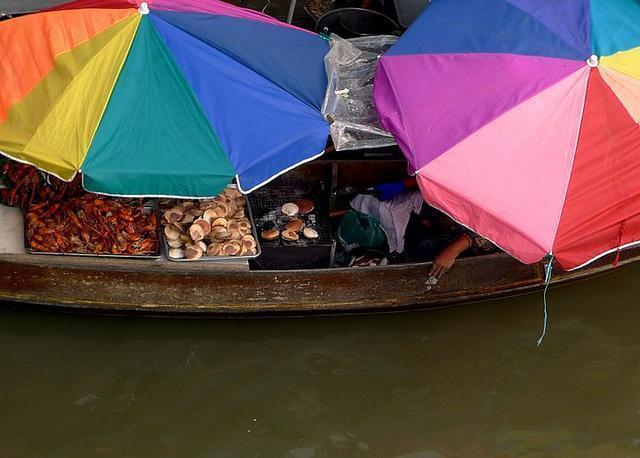What sort of food is being moved here?
Answer the question by selecting the correct answer among the 4 following choices and explain your choice with a short sentence. The answer should be formatted with the following format: `Answer: choice
Rationale: rationale.`
Options: Seafood, goat, chicken, beef. Answer: seafood.
Rationale: Shellfish and other seafood can be clearly seen. beef, chicken, and goat do not come in shells. 